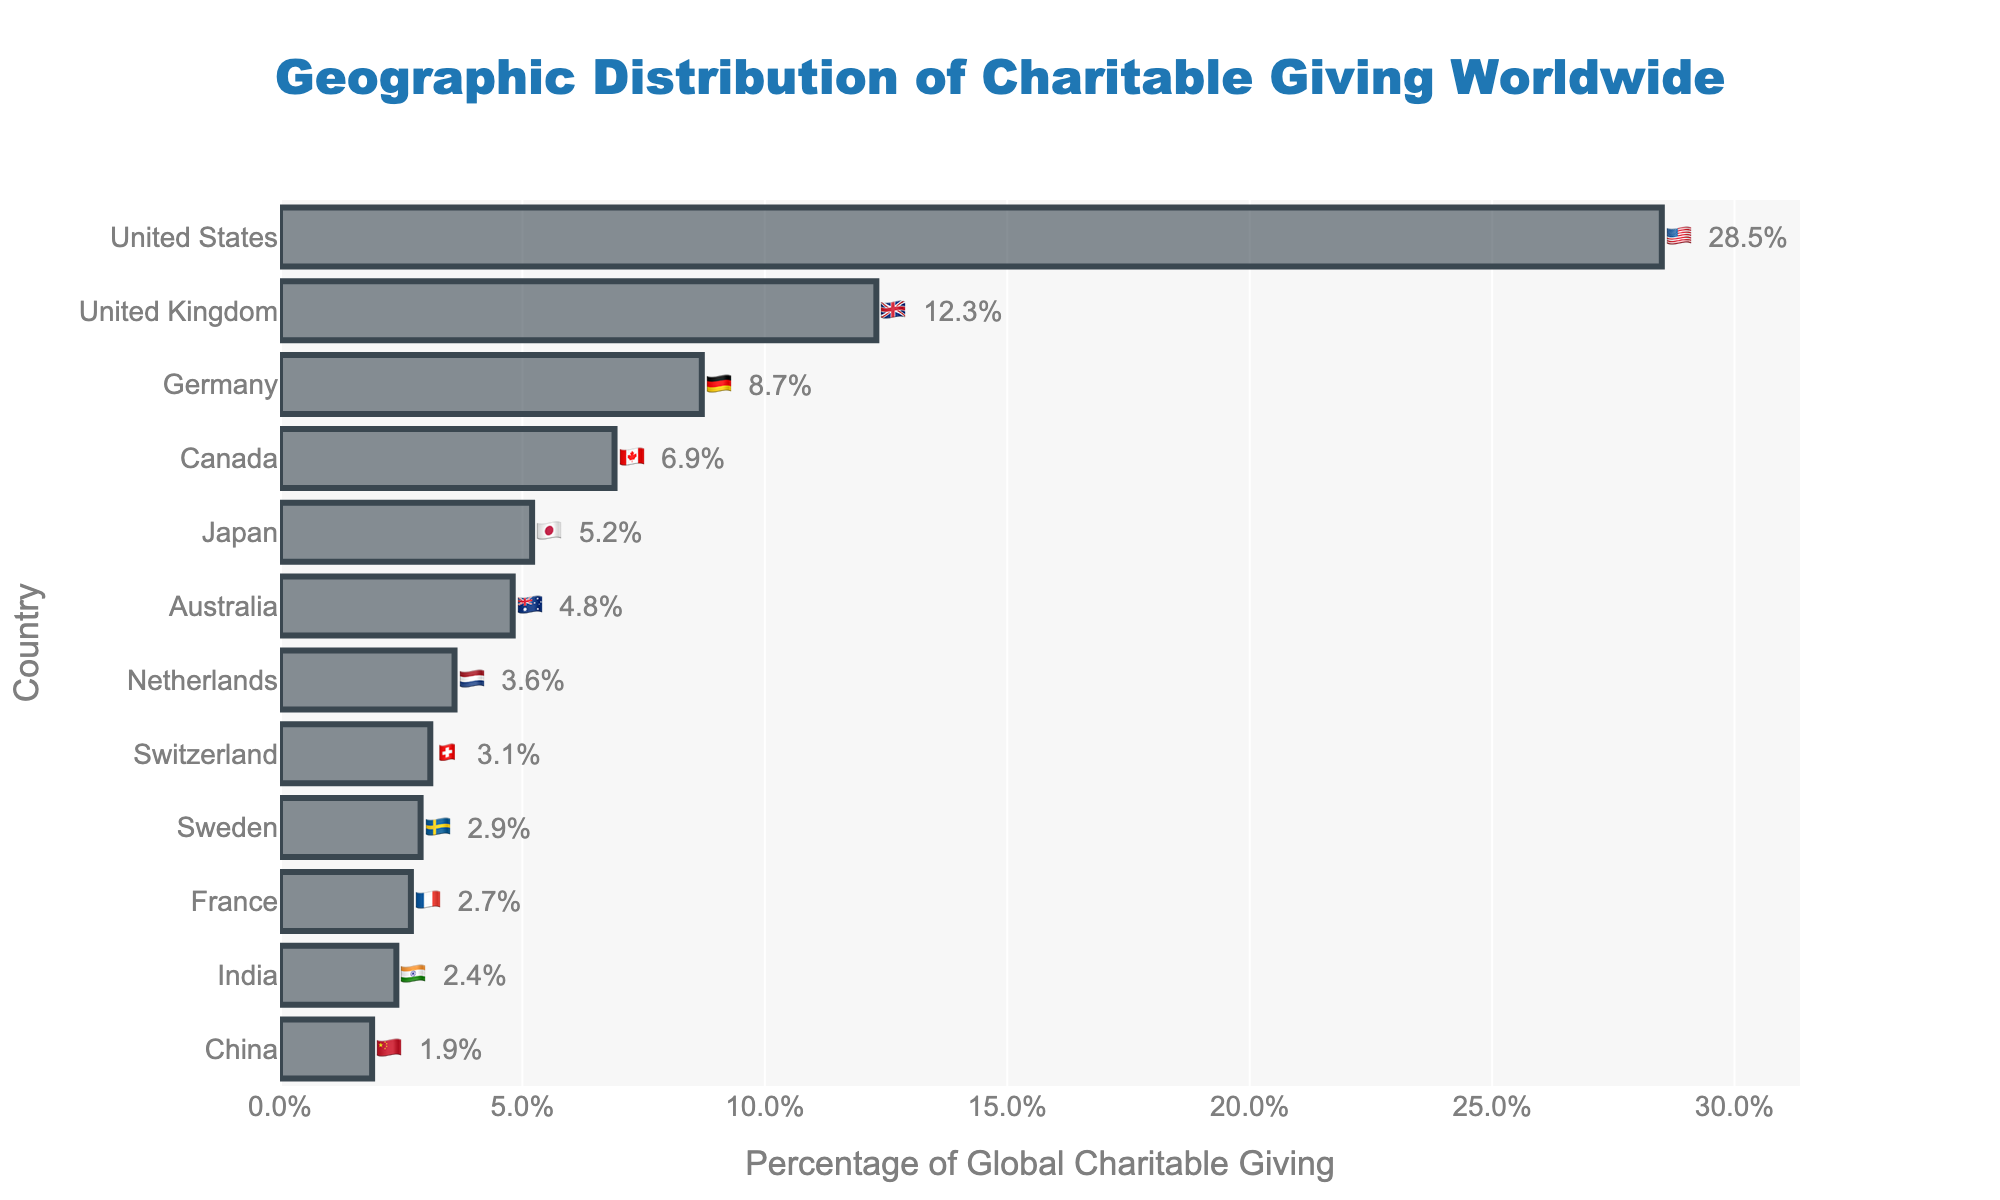Which country contributes the most to global charitable giving? The figure shows the geographic distribution of charitable giving with percentages. The bar for 🇺🇸 United States is the largest.
Answer: United States 🇺🇸 Which country has the lowest percentage of global charitable giving in this dataset? The figure shows the smallest bar, which is for 🇨🇳 China.
Answer: China 🇨🇳 What is the percentage of global charitable giving attributed to Japan? Find the bar next to the flag of 🇯🇵 Japan, which shows a percentage of 5.2%.
Answer: 5.2% What are the two countries with percentages closest to each other, and what are their percentages? The figure shows that 🇸🇪 Sweden (2.9%) and 🇫🇷 France (2.7%) have the closest percentages.
Answer: Sweden 🇸🇪 (2.9%) and France 🇫🇷 (2.7%) By how much does the percentage of global charitable giving in the United States exceed that of the United Kingdom? The figure shows the United States at 28.5% and the United Kingdom at 12.3%. The difference is 28.5% - 12.3%.
Answer: 16.2% Calculate the total percentage of global charitable giving for the top three contributing countries. The top three countries are the United States (28.5%), the United Kingdom (12.3%), and Germany (8.7%). Sum them up: 28.5% + 12.3% + 8.7%.
Answer: 49.5% What is the combined percentage of global charitable giving for Australia, the Netherlands, and Switzerland? Australia (4.8%), Netherlands (3.6%), and Switzerland (3.1%). Sum them up: 4.8% + 3.6% + 3.1%.
Answer: 11.5% Which country contributes more to global charitable giving: Canada or Japan? The figure shows that 🇨🇦 Canada contributes 6.9% and 🇯🇵 Japan contributes 5.2%.
Answer: Canada 🇨🇦 What is the average percentage of global charitable giving for the countries in this dataset? Sum all percentages and divide by the number of countries: (28.5 + 12.3 + 8.7 + 6.9 + 5.2 + 4.8 + 3.6 + 3.1 + 2.9 + 2.7 + 2.4 + 1.9) / 12.
Answer: 6.82% What's the median percentage of global charitable giving in this dataset? To find the median, rank the values and find the middle one. For 12 countries, it's the average of the 6th and 7th values: (4.8 + 3.6) / 2.
Answer: 4.2% 